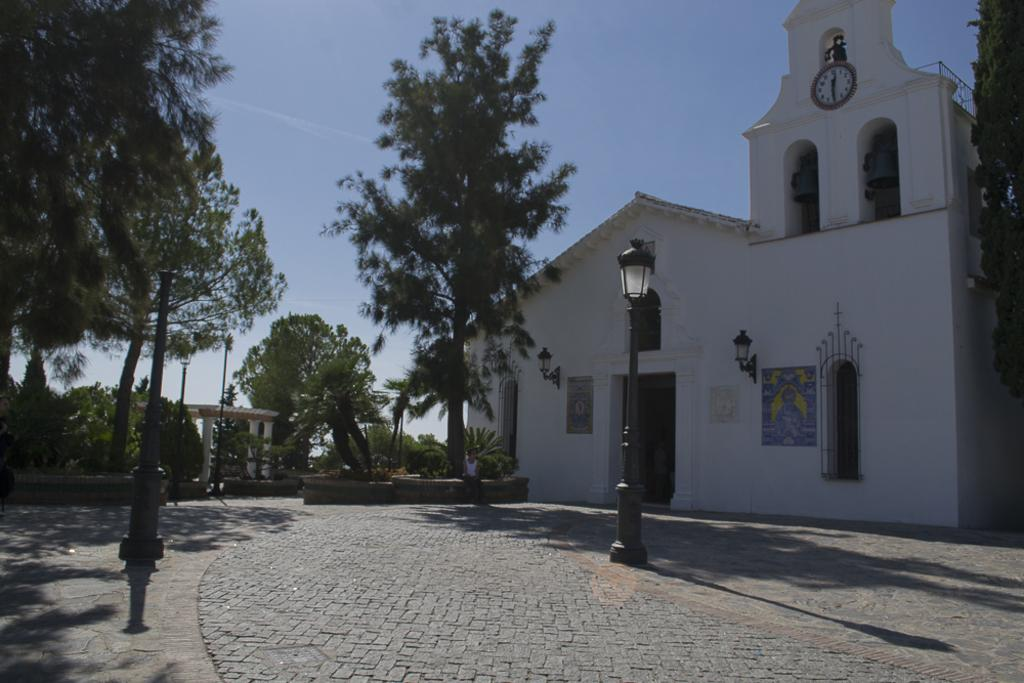What structure is the main subject of the image? There is a building in the image. Can you describe the person in the image? There is a person in front of the building. What other objects can be seen in the image? Street light poles and trees are visible in the image. What is visible in the background of the image? The sky is visible in the image. What type of locket is the person wearing around their neck in the image? There is no locket visible around the person's neck in the image. Can you describe the donkey that is standing next to the building in the image? There is no donkey present in the image; only the building, person, street light poles, trees, and sky are visible. 